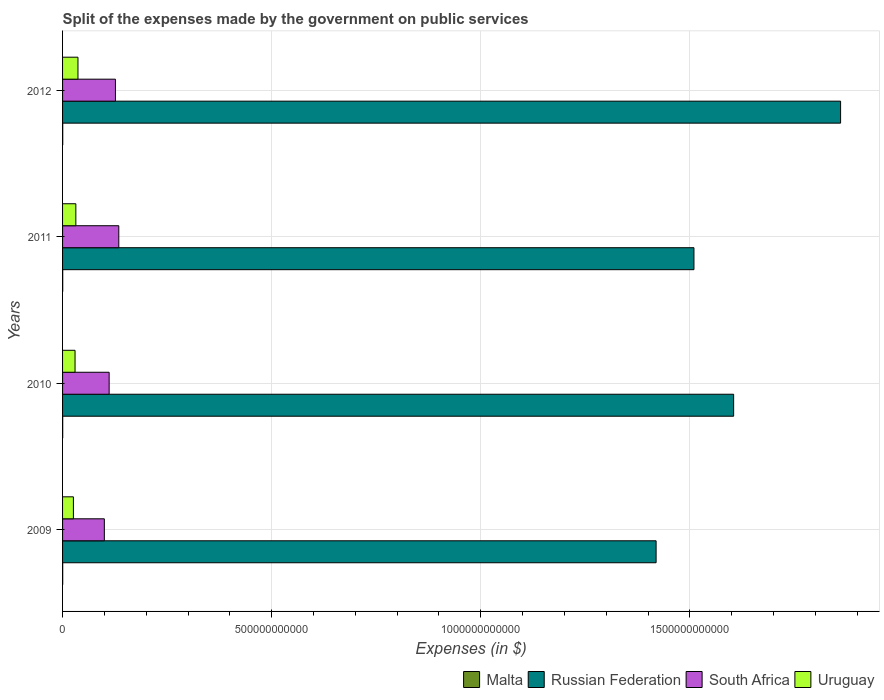How many different coloured bars are there?
Your answer should be very brief. 4. Are the number of bars per tick equal to the number of legend labels?
Give a very brief answer. Yes. How many bars are there on the 3rd tick from the top?
Offer a very short reply. 4. What is the label of the 4th group of bars from the top?
Ensure brevity in your answer.  2009. In how many cases, is the number of bars for a given year not equal to the number of legend labels?
Your answer should be very brief. 0. What is the expenses made by the government on public services in South Africa in 2009?
Your answer should be very brief. 9.99e+1. Across all years, what is the maximum expenses made by the government on public services in Uruguay?
Your response must be concise. 3.68e+1. Across all years, what is the minimum expenses made by the government on public services in South Africa?
Provide a succinct answer. 9.99e+1. In which year was the expenses made by the government on public services in South Africa minimum?
Make the answer very short. 2009. What is the total expenses made by the government on public services in Uruguay in the graph?
Your answer should be very brief. 1.24e+11. What is the difference between the expenses made by the government on public services in Uruguay in 2009 and that in 2010?
Your response must be concise. -3.95e+09. What is the difference between the expenses made by the government on public services in Malta in 2009 and the expenses made by the government on public services in Russian Federation in 2011?
Provide a short and direct response. -1.51e+12. What is the average expenses made by the government on public services in Malta per year?
Give a very brief answer. 3.64e+08. In the year 2009, what is the difference between the expenses made by the government on public services in South Africa and expenses made by the government on public services in Malta?
Offer a terse response. 9.96e+1. In how many years, is the expenses made by the government on public services in South Africa greater than 1200000000000 $?
Offer a terse response. 0. What is the ratio of the expenses made by the government on public services in Uruguay in 2009 to that in 2011?
Offer a terse response. 0.82. Is the difference between the expenses made by the government on public services in South Africa in 2009 and 2011 greater than the difference between the expenses made by the government on public services in Malta in 2009 and 2011?
Your answer should be very brief. No. What is the difference between the highest and the second highest expenses made by the government on public services in Russian Federation?
Ensure brevity in your answer.  2.56e+11. What is the difference between the highest and the lowest expenses made by the government on public services in South Africa?
Your response must be concise. 3.46e+1. Is it the case that in every year, the sum of the expenses made by the government on public services in Russian Federation and expenses made by the government on public services in Malta is greater than the sum of expenses made by the government on public services in South Africa and expenses made by the government on public services in Uruguay?
Provide a succinct answer. Yes. What does the 4th bar from the top in 2010 represents?
Your answer should be compact. Malta. What does the 3rd bar from the bottom in 2011 represents?
Your response must be concise. South Africa. Is it the case that in every year, the sum of the expenses made by the government on public services in Russian Federation and expenses made by the government on public services in South Africa is greater than the expenses made by the government on public services in Uruguay?
Your response must be concise. Yes. How many bars are there?
Your answer should be compact. 16. How many years are there in the graph?
Your answer should be very brief. 4. What is the difference between two consecutive major ticks on the X-axis?
Offer a very short reply. 5.00e+11. Where does the legend appear in the graph?
Offer a very short reply. Bottom right. How many legend labels are there?
Ensure brevity in your answer.  4. How are the legend labels stacked?
Your answer should be very brief. Horizontal. What is the title of the graph?
Provide a succinct answer. Split of the expenses made by the government on public services. Does "Gambia, The" appear as one of the legend labels in the graph?
Keep it short and to the point. No. What is the label or title of the X-axis?
Ensure brevity in your answer.  Expenses (in $). What is the Expenses (in $) of Malta in 2009?
Ensure brevity in your answer.  3.22e+08. What is the Expenses (in $) of Russian Federation in 2009?
Your response must be concise. 1.42e+12. What is the Expenses (in $) in South Africa in 2009?
Your response must be concise. 9.99e+1. What is the Expenses (in $) of Uruguay in 2009?
Your answer should be very brief. 2.59e+1. What is the Expenses (in $) of Malta in 2010?
Offer a very short reply. 3.41e+08. What is the Expenses (in $) of Russian Federation in 2010?
Give a very brief answer. 1.60e+12. What is the Expenses (in $) in South Africa in 2010?
Offer a very short reply. 1.11e+11. What is the Expenses (in $) in Uruguay in 2010?
Your response must be concise. 2.99e+1. What is the Expenses (in $) of Malta in 2011?
Offer a terse response. 3.76e+08. What is the Expenses (in $) in Russian Federation in 2011?
Give a very brief answer. 1.51e+12. What is the Expenses (in $) of South Africa in 2011?
Your answer should be very brief. 1.34e+11. What is the Expenses (in $) in Uruguay in 2011?
Make the answer very short. 3.17e+1. What is the Expenses (in $) in Malta in 2012?
Provide a short and direct response. 4.14e+08. What is the Expenses (in $) in Russian Federation in 2012?
Offer a terse response. 1.86e+12. What is the Expenses (in $) of South Africa in 2012?
Make the answer very short. 1.26e+11. What is the Expenses (in $) of Uruguay in 2012?
Provide a short and direct response. 3.68e+1. Across all years, what is the maximum Expenses (in $) in Malta?
Provide a succinct answer. 4.14e+08. Across all years, what is the maximum Expenses (in $) of Russian Federation?
Offer a very short reply. 1.86e+12. Across all years, what is the maximum Expenses (in $) of South Africa?
Your answer should be compact. 1.34e+11. Across all years, what is the maximum Expenses (in $) of Uruguay?
Offer a terse response. 3.68e+1. Across all years, what is the minimum Expenses (in $) of Malta?
Make the answer very short. 3.22e+08. Across all years, what is the minimum Expenses (in $) of Russian Federation?
Offer a very short reply. 1.42e+12. Across all years, what is the minimum Expenses (in $) of South Africa?
Your answer should be very brief. 9.99e+1. Across all years, what is the minimum Expenses (in $) of Uruguay?
Your response must be concise. 2.59e+1. What is the total Expenses (in $) in Malta in the graph?
Your response must be concise. 1.45e+09. What is the total Expenses (in $) in Russian Federation in the graph?
Make the answer very short. 6.39e+12. What is the total Expenses (in $) of South Africa in the graph?
Provide a short and direct response. 4.72e+11. What is the total Expenses (in $) in Uruguay in the graph?
Make the answer very short. 1.24e+11. What is the difference between the Expenses (in $) in Malta in 2009 and that in 2010?
Give a very brief answer. -1.87e+07. What is the difference between the Expenses (in $) in Russian Federation in 2009 and that in 2010?
Provide a succinct answer. -1.85e+11. What is the difference between the Expenses (in $) in South Africa in 2009 and that in 2010?
Your response must be concise. -1.15e+1. What is the difference between the Expenses (in $) of Uruguay in 2009 and that in 2010?
Keep it short and to the point. -3.95e+09. What is the difference between the Expenses (in $) in Malta in 2009 and that in 2011?
Your answer should be compact. -5.41e+07. What is the difference between the Expenses (in $) of Russian Federation in 2009 and that in 2011?
Ensure brevity in your answer.  -9.05e+1. What is the difference between the Expenses (in $) in South Africa in 2009 and that in 2011?
Offer a very short reply. -3.46e+1. What is the difference between the Expenses (in $) in Uruguay in 2009 and that in 2011?
Make the answer very short. -5.84e+09. What is the difference between the Expenses (in $) of Malta in 2009 and that in 2012?
Your response must be concise. -9.21e+07. What is the difference between the Expenses (in $) of Russian Federation in 2009 and that in 2012?
Offer a very short reply. -4.41e+11. What is the difference between the Expenses (in $) in South Africa in 2009 and that in 2012?
Offer a terse response. -2.65e+1. What is the difference between the Expenses (in $) in Uruguay in 2009 and that in 2012?
Your answer should be very brief. -1.09e+1. What is the difference between the Expenses (in $) in Malta in 2010 and that in 2011?
Give a very brief answer. -3.53e+07. What is the difference between the Expenses (in $) of Russian Federation in 2010 and that in 2011?
Make the answer very short. 9.49e+1. What is the difference between the Expenses (in $) of South Africa in 2010 and that in 2011?
Give a very brief answer. -2.31e+1. What is the difference between the Expenses (in $) of Uruguay in 2010 and that in 2011?
Your response must be concise. -1.89e+09. What is the difference between the Expenses (in $) of Malta in 2010 and that in 2012?
Provide a succinct answer. -7.33e+07. What is the difference between the Expenses (in $) of Russian Federation in 2010 and that in 2012?
Provide a short and direct response. -2.56e+11. What is the difference between the Expenses (in $) of South Africa in 2010 and that in 2012?
Your answer should be compact. -1.50e+1. What is the difference between the Expenses (in $) in Uruguay in 2010 and that in 2012?
Ensure brevity in your answer.  -6.97e+09. What is the difference between the Expenses (in $) in Malta in 2011 and that in 2012?
Provide a short and direct response. -3.80e+07. What is the difference between the Expenses (in $) in Russian Federation in 2011 and that in 2012?
Give a very brief answer. -3.51e+11. What is the difference between the Expenses (in $) of South Africa in 2011 and that in 2012?
Keep it short and to the point. 8.03e+09. What is the difference between the Expenses (in $) of Uruguay in 2011 and that in 2012?
Make the answer very short. -5.08e+09. What is the difference between the Expenses (in $) of Malta in 2009 and the Expenses (in $) of Russian Federation in 2010?
Keep it short and to the point. -1.60e+12. What is the difference between the Expenses (in $) of Malta in 2009 and the Expenses (in $) of South Africa in 2010?
Provide a succinct answer. -1.11e+11. What is the difference between the Expenses (in $) of Malta in 2009 and the Expenses (in $) of Uruguay in 2010?
Give a very brief answer. -2.95e+1. What is the difference between the Expenses (in $) of Russian Federation in 2009 and the Expenses (in $) of South Africa in 2010?
Your answer should be very brief. 1.31e+12. What is the difference between the Expenses (in $) of Russian Federation in 2009 and the Expenses (in $) of Uruguay in 2010?
Offer a very short reply. 1.39e+12. What is the difference between the Expenses (in $) of South Africa in 2009 and the Expenses (in $) of Uruguay in 2010?
Make the answer very short. 7.00e+1. What is the difference between the Expenses (in $) of Malta in 2009 and the Expenses (in $) of Russian Federation in 2011?
Your answer should be compact. -1.51e+12. What is the difference between the Expenses (in $) in Malta in 2009 and the Expenses (in $) in South Africa in 2011?
Make the answer very short. -1.34e+11. What is the difference between the Expenses (in $) of Malta in 2009 and the Expenses (in $) of Uruguay in 2011?
Your response must be concise. -3.14e+1. What is the difference between the Expenses (in $) of Russian Federation in 2009 and the Expenses (in $) of South Africa in 2011?
Your answer should be compact. 1.28e+12. What is the difference between the Expenses (in $) in Russian Federation in 2009 and the Expenses (in $) in Uruguay in 2011?
Your answer should be compact. 1.39e+12. What is the difference between the Expenses (in $) of South Africa in 2009 and the Expenses (in $) of Uruguay in 2011?
Your answer should be very brief. 6.81e+1. What is the difference between the Expenses (in $) in Malta in 2009 and the Expenses (in $) in Russian Federation in 2012?
Your response must be concise. -1.86e+12. What is the difference between the Expenses (in $) of Malta in 2009 and the Expenses (in $) of South Africa in 2012?
Offer a terse response. -1.26e+11. What is the difference between the Expenses (in $) of Malta in 2009 and the Expenses (in $) of Uruguay in 2012?
Your answer should be very brief. -3.65e+1. What is the difference between the Expenses (in $) of Russian Federation in 2009 and the Expenses (in $) of South Africa in 2012?
Offer a very short reply. 1.29e+12. What is the difference between the Expenses (in $) in Russian Federation in 2009 and the Expenses (in $) in Uruguay in 2012?
Offer a very short reply. 1.38e+12. What is the difference between the Expenses (in $) in South Africa in 2009 and the Expenses (in $) in Uruguay in 2012?
Make the answer very short. 6.30e+1. What is the difference between the Expenses (in $) in Malta in 2010 and the Expenses (in $) in Russian Federation in 2011?
Provide a succinct answer. -1.51e+12. What is the difference between the Expenses (in $) in Malta in 2010 and the Expenses (in $) in South Africa in 2011?
Keep it short and to the point. -1.34e+11. What is the difference between the Expenses (in $) of Malta in 2010 and the Expenses (in $) of Uruguay in 2011?
Offer a terse response. -3.14e+1. What is the difference between the Expenses (in $) of Russian Federation in 2010 and the Expenses (in $) of South Africa in 2011?
Offer a very short reply. 1.47e+12. What is the difference between the Expenses (in $) in Russian Federation in 2010 and the Expenses (in $) in Uruguay in 2011?
Your answer should be very brief. 1.57e+12. What is the difference between the Expenses (in $) in South Africa in 2010 and the Expenses (in $) in Uruguay in 2011?
Provide a succinct answer. 7.96e+1. What is the difference between the Expenses (in $) in Malta in 2010 and the Expenses (in $) in Russian Federation in 2012?
Make the answer very short. -1.86e+12. What is the difference between the Expenses (in $) of Malta in 2010 and the Expenses (in $) of South Africa in 2012?
Make the answer very short. -1.26e+11. What is the difference between the Expenses (in $) of Malta in 2010 and the Expenses (in $) of Uruguay in 2012?
Provide a succinct answer. -3.65e+1. What is the difference between the Expenses (in $) of Russian Federation in 2010 and the Expenses (in $) of South Africa in 2012?
Make the answer very short. 1.48e+12. What is the difference between the Expenses (in $) of Russian Federation in 2010 and the Expenses (in $) of Uruguay in 2012?
Give a very brief answer. 1.57e+12. What is the difference between the Expenses (in $) in South Africa in 2010 and the Expenses (in $) in Uruguay in 2012?
Keep it short and to the point. 7.45e+1. What is the difference between the Expenses (in $) in Malta in 2011 and the Expenses (in $) in Russian Federation in 2012?
Offer a terse response. -1.86e+12. What is the difference between the Expenses (in $) of Malta in 2011 and the Expenses (in $) of South Africa in 2012?
Keep it short and to the point. -1.26e+11. What is the difference between the Expenses (in $) of Malta in 2011 and the Expenses (in $) of Uruguay in 2012?
Ensure brevity in your answer.  -3.65e+1. What is the difference between the Expenses (in $) of Russian Federation in 2011 and the Expenses (in $) of South Africa in 2012?
Your answer should be compact. 1.38e+12. What is the difference between the Expenses (in $) in Russian Federation in 2011 and the Expenses (in $) in Uruguay in 2012?
Provide a short and direct response. 1.47e+12. What is the difference between the Expenses (in $) of South Africa in 2011 and the Expenses (in $) of Uruguay in 2012?
Your answer should be compact. 9.76e+1. What is the average Expenses (in $) of Malta per year?
Keep it short and to the point. 3.64e+08. What is the average Expenses (in $) of Russian Federation per year?
Offer a very short reply. 1.60e+12. What is the average Expenses (in $) of South Africa per year?
Offer a terse response. 1.18e+11. What is the average Expenses (in $) of Uruguay per year?
Make the answer very short. 3.11e+1. In the year 2009, what is the difference between the Expenses (in $) of Malta and Expenses (in $) of Russian Federation?
Offer a terse response. -1.42e+12. In the year 2009, what is the difference between the Expenses (in $) in Malta and Expenses (in $) in South Africa?
Provide a short and direct response. -9.96e+1. In the year 2009, what is the difference between the Expenses (in $) of Malta and Expenses (in $) of Uruguay?
Your answer should be very brief. -2.56e+1. In the year 2009, what is the difference between the Expenses (in $) in Russian Federation and Expenses (in $) in South Africa?
Offer a very short reply. 1.32e+12. In the year 2009, what is the difference between the Expenses (in $) in Russian Federation and Expenses (in $) in Uruguay?
Give a very brief answer. 1.39e+12. In the year 2009, what is the difference between the Expenses (in $) of South Africa and Expenses (in $) of Uruguay?
Ensure brevity in your answer.  7.40e+1. In the year 2010, what is the difference between the Expenses (in $) in Malta and Expenses (in $) in Russian Federation?
Your response must be concise. -1.60e+12. In the year 2010, what is the difference between the Expenses (in $) of Malta and Expenses (in $) of South Africa?
Your answer should be very brief. -1.11e+11. In the year 2010, what is the difference between the Expenses (in $) in Malta and Expenses (in $) in Uruguay?
Make the answer very short. -2.95e+1. In the year 2010, what is the difference between the Expenses (in $) in Russian Federation and Expenses (in $) in South Africa?
Give a very brief answer. 1.49e+12. In the year 2010, what is the difference between the Expenses (in $) in Russian Federation and Expenses (in $) in Uruguay?
Your answer should be compact. 1.57e+12. In the year 2010, what is the difference between the Expenses (in $) in South Africa and Expenses (in $) in Uruguay?
Provide a succinct answer. 8.15e+1. In the year 2011, what is the difference between the Expenses (in $) of Malta and Expenses (in $) of Russian Federation?
Provide a succinct answer. -1.51e+12. In the year 2011, what is the difference between the Expenses (in $) of Malta and Expenses (in $) of South Africa?
Make the answer very short. -1.34e+11. In the year 2011, what is the difference between the Expenses (in $) of Malta and Expenses (in $) of Uruguay?
Your answer should be very brief. -3.14e+1. In the year 2011, what is the difference between the Expenses (in $) of Russian Federation and Expenses (in $) of South Africa?
Ensure brevity in your answer.  1.38e+12. In the year 2011, what is the difference between the Expenses (in $) in Russian Federation and Expenses (in $) in Uruguay?
Ensure brevity in your answer.  1.48e+12. In the year 2011, what is the difference between the Expenses (in $) of South Africa and Expenses (in $) of Uruguay?
Your answer should be compact. 1.03e+11. In the year 2012, what is the difference between the Expenses (in $) in Malta and Expenses (in $) in Russian Federation?
Ensure brevity in your answer.  -1.86e+12. In the year 2012, what is the difference between the Expenses (in $) of Malta and Expenses (in $) of South Africa?
Provide a short and direct response. -1.26e+11. In the year 2012, what is the difference between the Expenses (in $) in Malta and Expenses (in $) in Uruguay?
Provide a short and direct response. -3.64e+1. In the year 2012, what is the difference between the Expenses (in $) in Russian Federation and Expenses (in $) in South Africa?
Your answer should be compact. 1.73e+12. In the year 2012, what is the difference between the Expenses (in $) of Russian Federation and Expenses (in $) of Uruguay?
Provide a short and direct response. 1.82e+12. In the year 2012, what is the difference between the Expenses (in $) of South Africa and Expenses (in $) of Uruguay?
Make the answer very short. 8.96e+1. What is the ratio of the Expenses (in $) of Malta in 2009 to that in 2010?
Offer a very short reply. 0.95. What is the ratio of the Expenses (in $) in Russian Federation in 2009 to that in 2010?
Your answer should be very brief. 0.88. What is the ratio of the Expenses (in $) of South Africa in 2009 to that in 2010?
Keep it short and to the point. 0.9. What is the ratio of the Expenses (in $) of Uruguay in 2009 to that in 2010?
Give a very brief answer. 0.87. What is the ratio of the Expenses (in $) in Malta in 2009 to that in 2011?
Your answer should be very brief. 0.86. What is the ratio of the Expenses (in $) in Russian Federation in 2009 to that in 2011?
Offer a very short reply. 0.94. What is the ratio of the Expenses (in $) of South Africa in 2009 to that in 2011?
Your answer should be very brief. 0.74. What is the ratio of the Expenses (in $) in Uruguay in 2009 to that in 2011?
Make the answer very short. 0.82. What is the ratio of the Expenses (in $) in Malta in 2009 to that in 2012?
Your answer should be compact. 0.78. What is the ratio of the Expenses (in $) in Russian Federation in 2009 to that in 2012?
Provide a short and direct response. 0.76. What is the ratio of the Expenses (in $) of South Africa in 2009 to that in 2012?
Provide a succinct answer. 0.79. What is the ratio of the Expenses (in $) in Uruguay in 2009 to that in 2012?
Make the answer very short. 0.7. What is the ratio of the Expenses (in $) of Malta in 2010 to that in 2011?
Your answer should be compact. 0.91. What is the ratio of the Expenses (in $) of Russian Federation in 2010 to that in 2011?
Make the answer very short. 1.06. What is the ratio of the Expenses (in $) of South Africa in 2010 to that in 2011?
Offer a terse response. 0.83. What is the ratio of the Expenses (in $) of Uruguay in 2010 to that in 2011?
Provide a short and direct response. 0.94. What is the ratio of the Expenses (in $) in Malta in 2010 to that in 2012?
Your answer should be very brief. 0.82. What is the ratio of the Expenses (in $) in Russian Federation in 2010 to that in 2012?
Make the answer very short. 0.86. What is the ratio of the Expenses (in $) of South Africa in 2010 to that in 2012?
Ensure brevity in your answer.  0.88. What is the ratio of the Expenses (in $) of Uruguay in 2010 to that in 2012?
Your response must be concise. 0.81. What is the ratio of the Expenses (in $) in Malta in 2011 to that in 2012?
Make the answer very short. 0.91. What is the ratio of the Expenses (in $) of Russian Federation in 2011 to that in 2012?
Your answer should be compact. 0.81. What is the ratio of the Expenses (in $) in South Africa in 2011 to that in 2012?
Offer a terse response. 1.06. What is the ratio of the Expenses (in $) of Uruguay in 2011 to that in 2012?
Your response must be concise. 0.86. What is the difference between the highest and the second highest Expenses (in $) of Malta?
Make the answer very short. 3.80e+07. What is the difference between the highest and the second highest Expenses (in $) in Russian Federation?
Your response must be concise. 2.56e+11. What is the difference between the highest and the second highest Expenses (in $) in South Africa?
Provide a succinct answer. 8.03e+09. What is the difference between the highest and the second highest Expenses (in $) in Uruguay?
Your response must be concise. 5.08e+09. What is the difference between the highest and the lowest Expenses (in $) of Malta?
Your answer should be very brief. 9.21e+07. What is the difference between the highest and the lowest Expenses (in $) of Russian Federation?
Your answer should be very brief. 4.41e+11. What is the difference between the highest and the lowest Expenses (in $) of South Africa?
Provide a succinct answer. 3.46e+1. What is the difference between the highest and the lowest Expenses (in $) of Uruguay?
Your answer should be compact. 1.09e+1. 